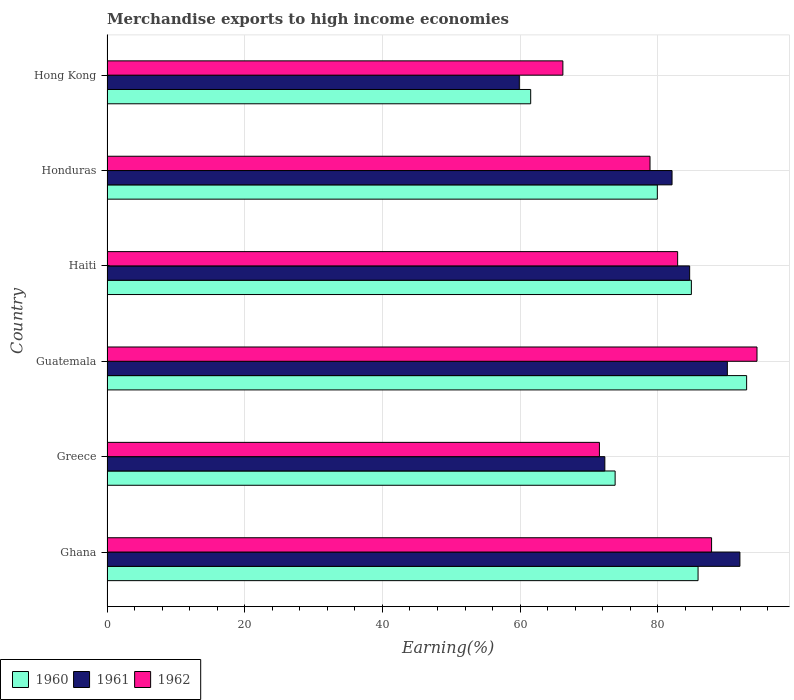How many different coloured bars are there?
Provide a succinct answer. 3. How many bars are there on the 2nd tick from the top?
Make the answer very short. 3. How many bars are there on the 2nd tick from the bottom?
Ensure brevity in your answer.  3. What is the label of the 4th group of bars from the top?
Offer a terse response. Guatemala. What is the percentage of amount earned from merchandise exports in 1962 in Haiti?
Keep it short and to the point. 82.89. Across all countries, what is the maximum percentage of amount earned from merchandise exports in 1961?
Make the answer very short. 91.93. Across all countries, what is the minimum percentage of amount earned from merchandise exports in 1962?
Give a very brief answer. 66.22. In which country was the percentage of amount earned from merchandise exports in 1960 maximum?
Keep it short and to the point. Guatemala. In which country was the percentage of amount earned from merchandise exports in 1962 minimum?
Your answer should be very brief. Hong Kong. What is the total percentage of amount earned from merchandise exports in 1961 in the graph?
Your answer should be very brief. 480.96. What is the difference between the percentage of amount earned from merchandise exports in 1960 in Guatemala and that in Hong Kong?
Ensure brevity in your answer.  31.36. What is the difference between the percentage of amount earned from merchandise exports in 1960 in Guatemala and the percentage of amount earned from merchandise exports in 1962 in Honduras?
Your answer should be very brief. 14.03. What is the average percentage of amount earned from merchandise exports in 1962 per country?
Ensure brevity in your answer.  80.29. What is the difference between the percentage of amount earned from merchandise exports in 1961 and percentage of amount earned from merchandise exports in 1960 in Guatemala?
Provide a short and direct response. -2.8. In how many countries, is the percentage of amount earned from merchandise exports in 1960 greater than 48 %?
Your answer should be very brief. 6. What is the ratio of the percentage of amount earned from merchandise exports in 1962 in Ghana to that in Hong Kong?
Give a very brief answer. 1.33. What is the difference between the highest and the second highest percentage of amount earned from merchandise exports in 1960?
Keep it short and to the point. 7.05. What is the difference between the highest and the lowest percentage of amount earned from merchandise exports in 1961?
Keep it short and to the point. 32.04. In how many countries, is the percentage of amount earned from merchandise exports in 1961 greater than the average percentage of amount earned from merchandise exports in 1961 taken over all countries?
Make the answer very short. 4. Is the sum of the percentage of amount earned from merchandise exports in 1960 in Honduras and Hong Kong greater than the maximum percentage of amount earned from merchandise exports in 1961 across all countries?
Your answer should be very brief. Yes. How many bars are there?
Your response must be concise. 18. How many countries are there in the graph?
Provide a short and direct response. 6. Are the values on the major ticks of X-axis written in scientific E-notation?
Provide a succinct answer. No. Does the graph contain grids?
Provide a succinct answer. Yes. Where does the legend appear in the graph?
Your response must be concise. Bottom left. How many legend labels are there?
Make the answer very short. 3. How are the legend labels stacked?
Ensure brevity in your answer.  Horizontal. What is the title of the graph?
Your answer should be very brief. Merchandise exports to high income economies. What is the label or title of the X-axis?
Make the answer very short. Earning(%). What is the Earning(%) in 1960 in Ghana?
Offer a terse response. 85.85. What is the Earning(%) in 1961 in Ghana?
Keep it short and to the point. 91.93. What is the Earning(%) of 1962 in Ghana?
Your answer should be compact. 87.82. What is the Earning(%) of 1960 in Greece?
Your response must be concise. 73.81. What is the Earning(%) in 1961 in Greece?
Your answer should be compact. 72.31. What is the Earning(%) in 1962 in Greece?
Keep it short and to the point. 71.53. What is the Earning(%) of 1960 in Guatemala?
Offer a terse response. 92.91. What is the Earning(%) of 1961 in Guatemala?
Your answer should be very brief. 90.11. What is the Earning(%) of 1962 in Guatemala?
Make the answer very short. 94.41. What is the Earning(%) in 1960 in Haiti?
Provide a succinct answer. 84.88. What is the Earning(%) of 1961 in Haiti?
Keep it short and to the point. 84.63. What is the Earning(%) in 1962 in Haiti?
Your answer should be very brief. 82.89. What is the Earning(%) in 1960 in Honduras?
Provide a succinct answer. 79.94. What is the Earning(%) in 1961 in Honduras?
Your answer should be compact. 82.07. What is the Earning(%) of 1962 in Honduras?
Give a very brief answer. 78.88. What is the Earning(%) of 1960 in Hong Kong?
Your answer should be very brief. 61.54. What is the Earning(%) in 1961 in Hong Kong?
Your answer should be very brief. 59.89. What is the Earning(%) in 1962 in Hong Kong?
Provide a succinct answer. 66.22. Across all countries, what is the maximum Earning(%) in 1960?
Your response must be concise. 92.91. Across all countries, what is the maximum Earning(%) in 1961?
Provide a succinct answer. 91.93. Across all countries, what is the maximum Earning(%) in 1962?
Offer a very short reply. 94.41. Across all countries, what is the minimum Earning(%) in 1960?
Offer a terse response. 61.54. Across all countries, what is the minimum Earning(%) of 1961?
Offer a terse response. 59.89. Across all countries, what is the minimum Earning(%) of 1962?
Your answer should be compact. 66.22. What is the total Earning(%) in 1960 in the graph?
Offer a terse response. 478.93. What is the total Earning(%) in 1961 in the graph?
Offer a terse response. 480.96. What is the total Earning(%) of 1962 in the graph?
Your response must be concise. 481.74. What is the difference between the Earning(%) in 1960 in Ghana and that in Greece?
Ensure brevity in your answer.  12.05. What is the difference between the Earning(%) of 1961 in Ghana and that in Greece?
Your answer should be very brief. 19.62. What is the difference between the Earning(%) of 1962 in Ghana and that in Greece?
Make the answer very short. 16.29. What is the difference between the Earning(%) in 1960 in Ghana and that in Guatemala?
Offer a very short reply. -7.05. What is the difference between the Earning(%) in 1961 in Ghana and that in Guatemala?
Make the answer very short. 1.82. What is the difference between the Earning(%) in 1962 in Ghana and that in Guatemala?
Offer a very short reply. -6.6. What is the difference between the Earning(%) of 1960 in Ghana and that in Haiti?
Offer a very short reply. 0.97. What is the difference between the Earning(%) of 1961 in Ghana and that in Haiti?
Make the answer very short. 7.3. What is the difference between the Earning(%) in 1962 in Ghana and that in Haiti?
Provide a succinct answer. 4.93. What is the difference between the Earning(%) in 1960 in Ghana and that in Honduras?
Ensure brevity in your answer.  5.92. What is the difference between the Earning(%) in 1961 in Ghana and that in Honduras?
Your answer should be very brief. 9.86. What is the difference between the Earning(%) in 1962 in Ghana and that in Honduras?
Keep it short and to the point. 8.94. What is the difference between the Earning(%) in 1960 in Ghana and that in Hong Kong?
Provide a succinct answer. 24.31. What is the difference between the Earning(%) in 1961 in Ghana and that in Hong Kong?
Your response must be concise. 32.04. What is the difference between the Earning(%) in 1962 in Ghana and that in Hong Kong?
Your response must be concise. 21.6. What is the difference between the Earning(%) of 1960 in Greece and that in Guatemala?
Provide a succinct answer. -19.1. What is the difference between the Earning(%) of 1961 in Greece and that in Guatemala?
Your response must be concise. -17.79. What is the difference between the Earning(%) of 1962 in Greece and that in Guatemala?
Offer a terse response. -22.89. What is the difference between the Earning(%) of 1960 in Greece and that in Haiti?
Ensure brevity in your answer.  -11.08. What is the difference between the Earning(%) of 1961 in Greece and that in Haiti?
Offer a terse response. -12.32. What is the difference between the Earning(%) of 1962 in Greece and that in Haiti?
Give a very brief answer. -11.36. What is the difference between the Earning(%) in 1960 in Greece and that in Honduras?
Give a very brief answer. -6.13. What is the difference between the Earning(%) in 1961 in Greece and that in Honduras?
Ensure brevity in your answer.  -9.76. What is the difference between the Earning(%) of 1962 in Greece and that in Honduras?
Your answer should be very brief. -7.35. What is the difference between the Earning(%) in 1960 in Greece and that in Hong Kong?
Your answer should be compact. 12.26. What is the difference between the Earning(%) of 1961 in Greece and that in Hong Kong?
Offer a terse response. 12.42. What is the difference between the Earning(%) of 1962 in Greece and that in Hong Kong?
Ensure brevity in your answer.  5.31. What is the difference between the Earning(%) of 1960 in Guatemala and that in Haiti?
Keep it short and to the point. 8.02. What is the difference between the Earning(%) in 1961 in Guatemala and that in Haiti?
Ensure brevity in your answer.  5.48. What is the difference between the Earning(%) in 1962 in Guatemala and that in Haiti?
Ensure brevity in your answer.  11.53. What is the difference between the Earning(%) of 1960 in Guatemala and that in Honduras?
Give a very brief answer. 12.97. What is the difference between the Earning(%) of 1961 in Guatemala and that in Honduras?
Your response must be concise. 8.03. What is the difference between the Earning(%) of 1962 in Guatemala and that in Honduras?
Make the answer very short. 15.54. What is the difference between the Earning(%) of 1960 in Guatemala and that in Hong Kong?
Keep it short and to the point. 31.36. What is the difference between the Earning(%) in 1961 in Guatemala and that in Hong Kong?
Provide a succinct answer. 30.22. What is the difference between the Earning(%) of 1962 in Guatemala and that in Hong Kong?
Give a very brief answer. 28.2. What is the difference between the Earning(%) in 1960 in Haiti and that in Honduras?
Your answer should be very brief. 4.95. What is the difference between the Earning(%) of 1961 in Haiti and that in Honduras?
Keep it short and to the point. 2.56. What is the difference between the Earning(%) of 1962 in Haiti and that in Honduras?
Provide a short and direct response. 4.01. What is the difference between the Earning(%) in 1960 in Haiti and that in Hong Kong?
Your response must be concise. 23.34. What is the difference between the Earning(%) in 1961 in Haiti and that in Hong Kong?
Your answer should be very brief. 24.74. What is the difference between the Earning(%) in 1962 in Haiti and that in Hong Kong?
Offer a very short reply. 16.67. What is the difference between the Earning(%) in 1960 in Honduras and that in Hong Kong?
Keep it short and to the point. 18.39. What is the difference between the Earning(%) in 1961 in Honduras and that in Hong Kong?
Provide a succinct answer. 22.18. What is the difference between the Earning(%) of 1962 in Honduras and that in Hong Kong?
Offer a very short reply. 12.66. What is the difference between the Earning(%) of 1960 in Ghana and the Earning(%) of 1961 in Greece?
Your answer should be very brief. 13.54. What is the difference between the Earning(%) in 1960 in Ghana and the Earning(%) in 1962 in Greece?
Keep it short and to the point. 14.33. What is the difference between the Earning(%) of 1961 in Ghana and the Earning(%) of 1962 in Greece?
Provide a succinct answer. 20.41. What is the difference between the Earning(%) in 1960 in Ghana and the Earning(%) in 1961 in Guatemala?
Make the answer very short. -4.25. What is the difference between the Earning(%) in 1960 in Ghana and the Earning(%) in 1962 in Guatemala?
Offer a very short reply. -8.56. What is the difference between the Earning(%) in 1961 in Ghana and the Earning(%) in 1962 in Guatemala?
Provide a short and direct response. -2.48. What is the difference between the Earning(%) in 1960 in Ghana and the Earning(%) in 1961 in Haiti?
Provide a short and direct response. 1.22. What is the difference between the Earning(%) in 1960 in Ghana and the Earning(%) in 1962 in Haiti?
Your response must be concise. 2.97. What is the difference between the Earning(%) in 1961 in Ghana and the Earning(%) in 1962 in Haiti?
Give a very brief answer. 9.05. What is the difference between the Earning(%) in 1960 in Ghana and the Earning(%) in 1961 in Honduras?
Keep it short and to the point. 3.78. What is the difference between the Earning(%) of 1960 in Ghana and the Earning(%) of 1962 in Honduras?
Offer a very short reply. 6.98. What is the difference between the Earning(%) in 1961 in Ghana and the Earning(%) in 1962 in Honduras?
Provide a short and direct response. 13.06. What is the difference between the Earning(%) of 1960 in Ghana and the Earning(%) of 1961 in Hong Kong?
Your answer should be very brief. 25.96. What is the difference between the Earning(%) in 1960 in Ghana and the Earning(%) in 1962 in Hong Kong?
Make the answer very short. 19.64. What is the difference between the Earning(%) in 1961 in Ghana and the Earning(%) in 1962 in Hong Kong?
Your answer should be compact. 25.72. What is the difference between the Earning(%) of 1960 in Greece and the Earning(%) of 1961 in Guatemala?
Your answer should be compact. -16.3. What is the difference between the Earning(%) in 1960 in Greece and the Earning(%) in 1962 in Guatemala?
Make the answer very short. -20.61. What is the difference between the Earning(%) in 1961 in Greece and the Earning(%) in 1962 in Guatemala?
Ensure brevity in your answer.  -22.1. What is the difference between the Earning(%) in 1960 in Greece and the Earning(%) in 1961 in Haiti?
Make the answer very short. -10.83. What is the difference between the Earning(%) in 1960 in Greece and the Earning(%) in 1962 in Haiti?
Your answer should be very brief. -9.08. What is the difference between the Earning(%) in 1961 in Greece and the Earning(%) in 1962 in Haiti?
Ensure brevity in your answer.  -10.57. What is the difference between the Earning(%) of 1960 in Greece and the Earning(%) of 1961 in Honduras?
Give a very brief answer. -8.27. What is the difference between the Earning(%) of 1960 in Greece and the Earning(%) of 1962 in Honduras?
Offer a terse response. -5.07. What is the difference between the Earning(%) of 1961 in Greece and the Earning(%) of 1962 in Honduras?
Your answer should be very brief. -6.56. What is the difference between the Earning(%) of 1960 in Greece and the Earning(%) of 1961 in Hong Kong?
Offer a very short reply. 13.91. What is the difference between the Earning(%) in 1960 in Greece and the Earning(%) in 1962 in Hong Kong?
Keep it short and to the point. 7.59. What is the difference between the Earning(%) of 1961 in Greece and the Earning(%) of 1962 in Hong Kong?
Provide a succinct answer. 6.1. What is the difference between the Earning(%) of 1960 in Guatemala and the Earning(%) of 1961 in Haiti?
Provide a short and direct response. 8.27. What is the difference between the Earning(%) of 1960 in Guatemala and the Earning(%) of 1962 in Haiti?
Provide a short and direct response. 10.02. What is the difference between the Earning(%) of 1961 in Guatemala and the Earning(%) of 1962 in Haiti?
Give a very brief answer. 7.22. What is the difference between the Earning(%) in 1960 in Guatemala and the Earning(%) in 1961 in Honduras?
Offer a terse response. 10.83. What is the difference between the Earning(%) of 1960 in Guatemala and the Earning(%) of 1962 in Honduras?
Provide a succinct answer. 14.03. What is the difference between the Earning(%) of 1961 in Guatemala and the Earning(%) of 1962 in Honduras?
Offer a very short reply. 11.23. What is the difference between the Earning(%) of 1960 in Guatemala and the Earning(%) of 1961 in Hong Kong?
Your answer should be very brief. 33.02. What is the difference between the Earning(%) in 1960 in Guatemala and the Earning(%) in 1962 in Hong Kong?
Provide a succinct answer. 26.69. What is the difference between the Earning(%) in 1961 in Guatemala and the Earning(%) in 1962 in Hong Kong?
Make the answer very short. 23.89. What is the difference between the Earning(%) of 1960 in Haiti and the Earning(%) of 1961 in Honduras?
Ensure brevity in your answer.  2.81. What is the difference between the Earning(%) of 1960 in Haiti and the Earning(%) of 1962 in Honduras?
Keep it short and to the point. 6.01. What is the difference between the Earning(%) of 1961 in Haiti and the Earning(%) of 1962 in Honduras?
Keep it short and to the point. 5.76. What is the difference between the Earning(%) in 1960 in Haiti and the Earning(%) in 1961 in Hong Kong?
Provide a succinct answer. 24.99. What is the difference between the Earning(%) in 1960 in Haiti and the Earning(%) in 1962 in Hong Kong?
Ensure brevity in your answer.  18.67. What is the difference between the Earning(%) in 1961 in Haiti and the Earning(%) in 1962 in Hong Kong?
Offer a terse response. 18.42. What is the difference between the Earning(%) in 1960 in Honduras and the Earning(%) in 1961 in Hong Kong?
Ensure brevity in your answer.  20.05. What is the difference between the Earning(%) of 1960 in Honduras and the Earning(%) of 1962 in Hong Kong?
Provide a succinct answer. 13.72. What is the difference between the Earning(%) of 1961 in Honduras and the Earning(%) of 1962 in Hong Kong?
Ensure brevity in your answer.  15.86. What is the average Earning(%) in 1960 per country?
Offer a terse response. 79.82. What is the average Earning(%) in 1961 per country?
Give a very brief answer. 80.16. What is the average Earning(%) of 1962 per country?
Keep it short and to the point. 80.29. What is the difference between the Earning(%) in 1960 and Earning(%) in 1961 in Ghana?
Your answer should be very brief. -6.08. What is the difference between the Earning(%) of 1960 and Earning(%) of 1962 in Ghana?
Keep it short and to the point. -1.96. What is the difference between the Earning(%) in 1961 and Earning(%) in 1962 in Ghana?
Ensure brevity in your answer.  4.12. What is the difference between the Earning(%) in 1960 and Earning(%) in 1961 in Greece?
Provide a succinct answer. 1.49. What is the difference between the Earning(%) in 1960 and Earning(%) in 1962 in Greece?
Ensure brevity in your answer.  2.28. What is the difference between the Earning(%) in 1961 and Earning(%) in 1962 in Greece?
Your answer should be very brief. 0.79. What is the difference between the Earning(%) of 1960 and Earning(%) of 1961 in Guatemala?
Your response must be concise. 2.8. What is the difference between the Earning(%) in 1960 and Earning(%) in 1962 in Guatemala?
Your answer should be compact. -1.51. What is the difference between the Earning(%) in 1961 and Earning(%) in 1962 in Guatemala?
Provide a succinct answer. -4.3. What is the difference between the Earning(%) of 1960 and Earning(%) of 1961 in Haiti?
Your response must be concise. 0.25. What is the difference between the Earning(%) of 1960 and Earning(%) of 1962 in Haiti?
Your response must be concise. 2. What is the difference between the Earning(%) in 1961 and Earning(%) in 1962 in Haiti?
Provide a short and direct response. 1.75. What is the difference between the Earning(%) in 1960 and Earning(%) in 1961 in Honduras?
Your response must be concise. -2.14. What is the difference between the Earning(%) of 1960 and Earning(%) of 1962 in Honduras?
Ensure brevity in your answer.  1.06. What is the difference between the Earning(%) of 1961 and Earning(%) of 1962 in Honduras?
Your answer should be compact. 3.2. What is the difference between the Earning(%) in 1960 and Earning(%) in 1961 in Hong Kong?
Provide a short and direct response. 1.65. What is the difference between the Earning(%) in 1960 and Earning(%) in 1962 in Hong Kong?
Provide a short and direct response. -4.67. What is the difference between the Earning(%) in 1961 and Earning(%) in 1962 in Hong Kong?
Give a very brief answer. -6.32. What is the ratio of the Earning(%) in 1960 in Ghana to that in Greece?
Your answer should be compact. 1.16. What is the ratio of the Earning(%) of 1961 in Ghana to that in Greece?
Your response must be concise. 1.27. What is the ratio of the Earning(%) of 1962 in Ghana to that in Greece?
Provide a short and direct response. 1.23. What is the ratio of the Earning(%) in 1960 in Ghana to that in Guatemala?
Offer a very short reply. 0.92. What is the ratio of the Earning(%) of 1961 in Ghana to that in Guatemala?
Make the answer very short. 1.02. What is the ratio of the Earning(%) in 1962 in Ghana to that in Guatemala?
Ensure brevity in your answer.  0.93. What is the ratio of the Earning(%) of 1960 in Ghana to that in Haiti?
Your answer should be very brief. 1.01. What is the ratio of the Earning(%) of 1961 in Ghana to that in Haiti?
Provide a short and direct response. 1.09. What is the ratio of the Earning(%) of 1962 in Ghana to that in Haiti?
Provide a succinct answer. 1.06. What is the ratio of the Earning(%) of 1960 in Ghana to that in Honduras?
Keep it short and to the point. 1.07. What is the ratio of the Earning(%) in 1961 in Ghana to that in Honduras?
Ensure brevity in your answer.  1.12. What is the ratio of the Earning(%) of 1962 in Ghana to that in Honduras?
Your answer should be very brief. 1.11. What is the ratio of the Earning(%) of 1960 in Ghana to that in Hong Kong?
Provide a short and direct response. 1.4. What is the ratio of the Earning(%) in 1961 in Ghana to that in Hong Kong?
Your answer should be very brief. 1.53. What is the ratio of the Earning(%) of 1962 in Ghana to that in Hong Kong?
Keep it short and to the point. 1.33. What is the ratio of the Earning(%) in 1960 in Greece to that in Guatemala?
Offer a terse response. 0.79. What is the ratio of the Earning(%) in 1961 in Greece to that in Guatemala?
Your answer should be very brief. 0.8. What is the ratio of the Earning(%) in 1962 in Greece to that in Guatemala?
Keep it short and to the point. 0.76. What is the ratio of the Earning(%) of 1960 in Greece to that in Haiti?
Your response must be concise. 0.87. What is the ratio of the Earning(%) in 1961 in Greece to that in Haiti?
Give a very brief answer. 0.85. What is the ratio of the Earning(%) of 1962 in Greece to that in Haiti?
Provide a short and direct response. 0.86. What is the ratio of the Earning(%) of 1960 in Greece to that in Honduras?
Your answer should be very brief. 0.92. What is the ratio of the Earning(%) of 1961 in Greece to that in Honduras?
Offer a very short reply. 0.88. What is the ratio of the Earning(%) of 1962 in Greece to that in Honduras?
Offer a terse response. 0.91. What is the ratio of the Earning(%) of 1960 in Greece to that in Hong Kong?
Provide a succinct answer. 1.2. What is the ratio of the Earning(%) in 1961 in Greece to that in Hong Kong?
Ensure brevity in your answer.  1.21. What is the ratio of the Earning(%) in 1962 in Greece to that in Hong Kong?
Your answer should be compact. 1.08. What is the ratio of the Earning(%) of 1960 in Guatemala to that in Haiti?
Offer a terse response. 1.09. What is the ratio of the Earning(%) of 1961 in Guatemala to that in Haiti?
Offer a terse response. 1.06. What is the ratio of the Earning(%) of 1962 in Guatemala to that in Haiti?
Your response must be concise. 1.14. What is the ratio of the Earning(%) in 1960 in Guatemala to that in Honduras?
Your answer should be very brief. 1.16. What is the ratio of the Earning(%) of 1961 in Guatemala to that in Honduras?
Keep it short and to the point. 1.1. What is the ratio of the Earning(%) of 1962 in Guatemala to that in Honduras?
Provide a short and direct response. 1.2. What is the ratio of the Earning(%) in 1960 in Guatemala to that in Hong Kong?
Provide a succinct answer. 1.51. What is the ratio of the Earning(%) in 1961 in Guatemala to that in Hong Kong?
Provide a succinct answer. 1.5. What is the ratio of the Earning(%) of 1962 in Guatemala to that in Hong Kong?
Provide a short and direct response. 1.43. What is the ratio of the Earning(%) in 1960 in Haiti to that in Honduras?
Make the answer very short. 1.06. What is the ratio of the Earning(%) in 1961 in Haiti to that in Honduras?
Your response must be concise. 1.03. What is the ratio of the Earning(%) of 1962 in Haiti to that in Honduras?
Make the answer very short. 1.05. What is the ratio of the Earning(%) of 1960 in Haiti to that in Hong Kong?
Offer a terse response. 1.38. What is the ratio of the Earning(%) in 1961 in Haiti to that in Hong Kong?
Give a very brief answer. 1.41. What is the ratio of the Earning(%) in 1962 in Haiti to that in Hong Kong?
Your answer should be compact. 1.25. What is the ratio of the Earning(%) in 1960 in Honduras to that in Hong Kong?
Give a very brief answer. 1.3. What is the ratio of the Earning(%) of 1961 in Honduras to that in Hong Kong?
Provide a short and direct response. 1.37. What is the ratio of the Earning(%) of 1962 in Honduras to that in Hong Kong?
Keep it short and to the point. 1.19. What is the difference between the highest and the second highest Earning(%) of 1960?
Your response must be concise. 7.05. What is the difference between the highest and the second highest Earning(%) of 1961?
Your answer should be compact. 1.82. What is the difference between the highest and the second highest Earning(%) in 1962?
Ensure brevity in your answer.  6.6. What is the difference between the highest and the lowest Earning(%) of 1960?
Keep it short and to the point. 31.36. What is the difference between the highest and the lowest Earning(%) in 1961?
Keep it short and to the point. 32.04. What is the difference between the highest and the lowest Earning(%) of 1962?
Your answer should be very brief. 28.2. 